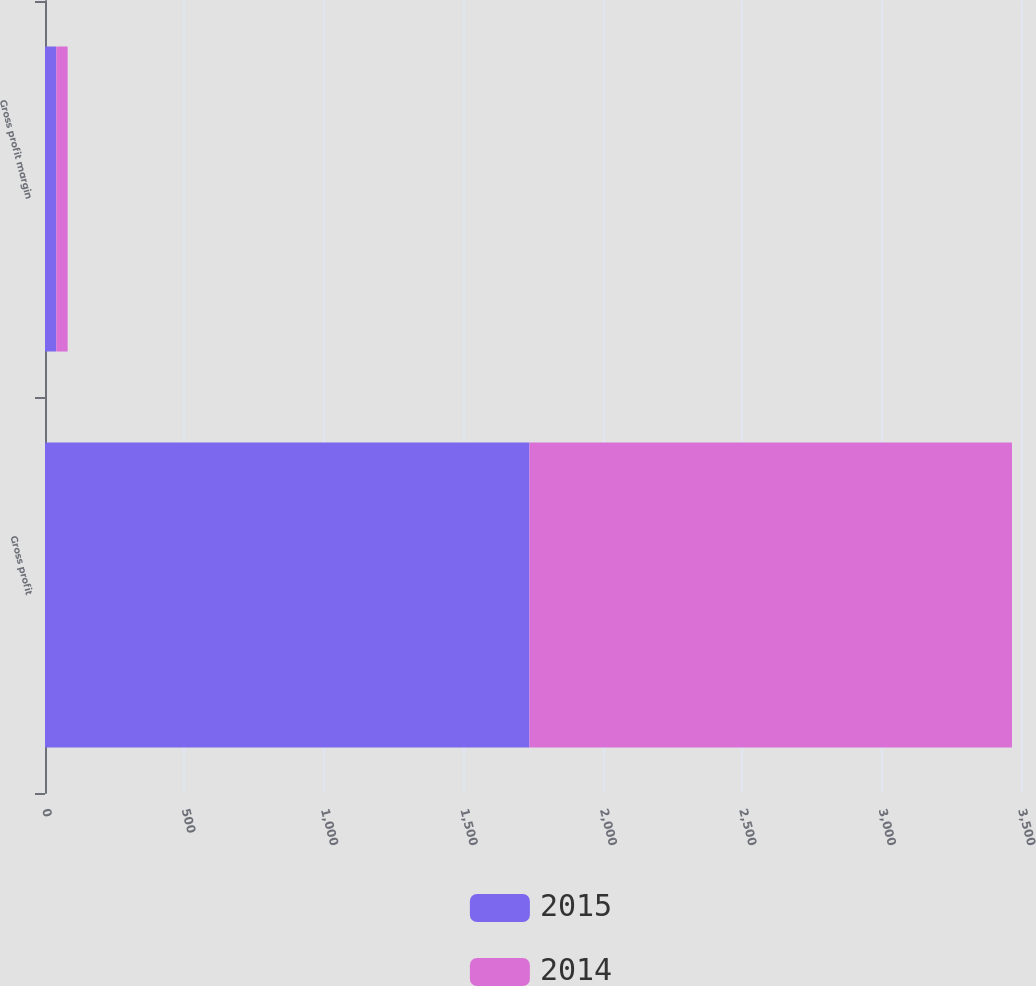Convert chart. <chart><loc_0><loc_0><loc_500><loc_500><stacked_bar_chart><ecel><fcel>Gross profit<fcel>Gross profit margin<nl><fcel>2015<fcel>1737.3<fcel>40.4<nl><fcel>2014<fcel>1730.2<fcel>40.8<nl></chart> 